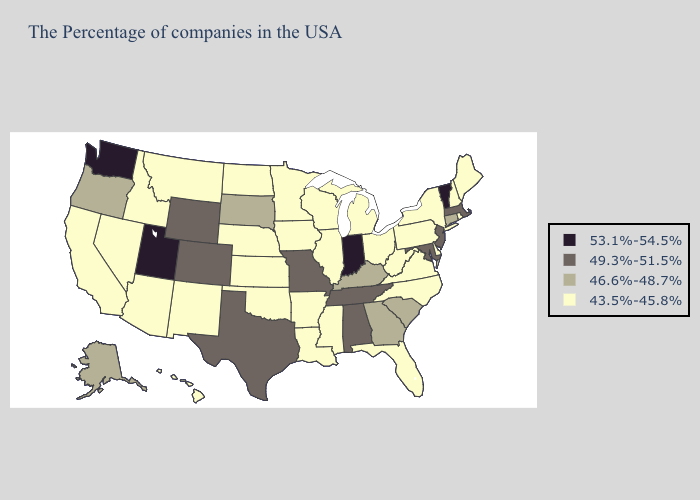Does the map have missing data?
Give a very brief answer. No. Does Arizona have the same value as Wyoming?
Quick response, please. No. Name the states that have a value in the range 53.1%-54.5%?
Be succinct. Vermont, Indiana, Utah, Washington. Does New Jersey have the highest value in the Northeast?
Write a very short answer. No. Among the states that border Michigan , does Ohio have the highest value?
Keep it brief. No. Does Mississippi have a lower value than Pennsylvania?
Give a very brief answer. No. Does Rhode Island have the same value as Georgia?
Write a very short answer. No. What is the value of New York?
Be succinct. 43.5%-45.8%. Among the states that border New Hampshire , does Maine have the lowest value?
Keep it brief. Yes. What is the lowest value in the USA?
Be succinct. 43.5%-45.8%. What is the value of Vermont?
Write a very short answer. 53.1%-54.5%. Among the states that border Nevada , does Utah have the lowest value?
Quick response, please. No. Among the states that border Indiana , does Michigan have the highest value?
Give a very brief answer. No. Does New Mexico have a lower value than Oregon?
Short answer required. Yes. 